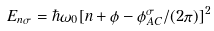<formula> <loc_0><loc_0><loc_500><loc_500>E _ { n \sigma } = \hbar { \omega } _ { 0 } [ n + \phi - \phi _ { A C } ^ { \sigma } / ( 2 \pi ) ] ^ { 2 }</formula> 